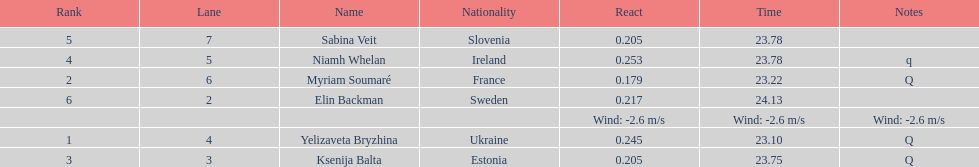How long did it take elin backman to finish the race? 24.13. 